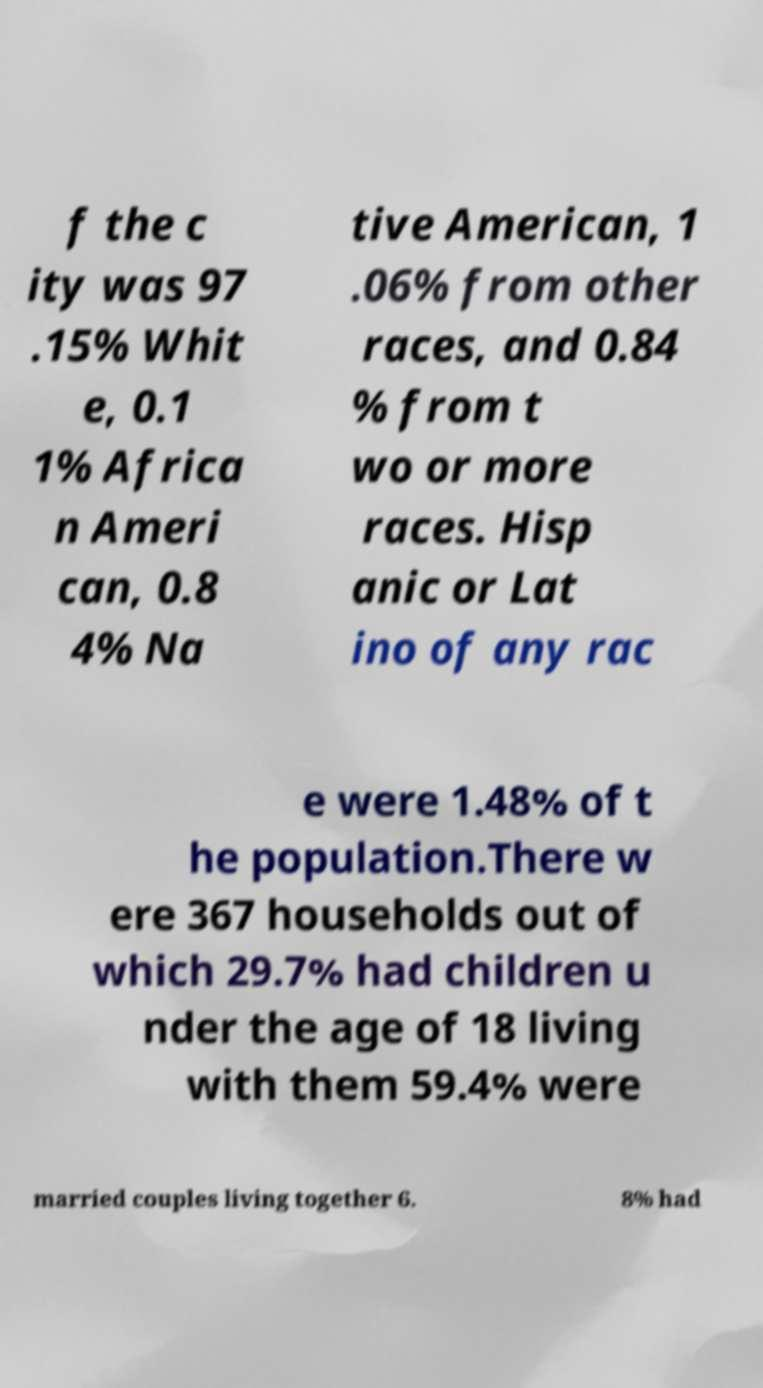Can you accurately transcribe the text from the provided image for me? f the c ity was 97 .15% Whit e, 0.1 1% Africa n Ameri can, 0.8 4% Na tive American, 1 .06% from other races, and 0.84 % from t wo or more races. Hisp anic or Lat ino of any rac e were 1.48% of t he population.There w ere 367 households out of which 29.7% had children u nder the age of 18 living with them 59.4% were married couples living together 6. 8% had 